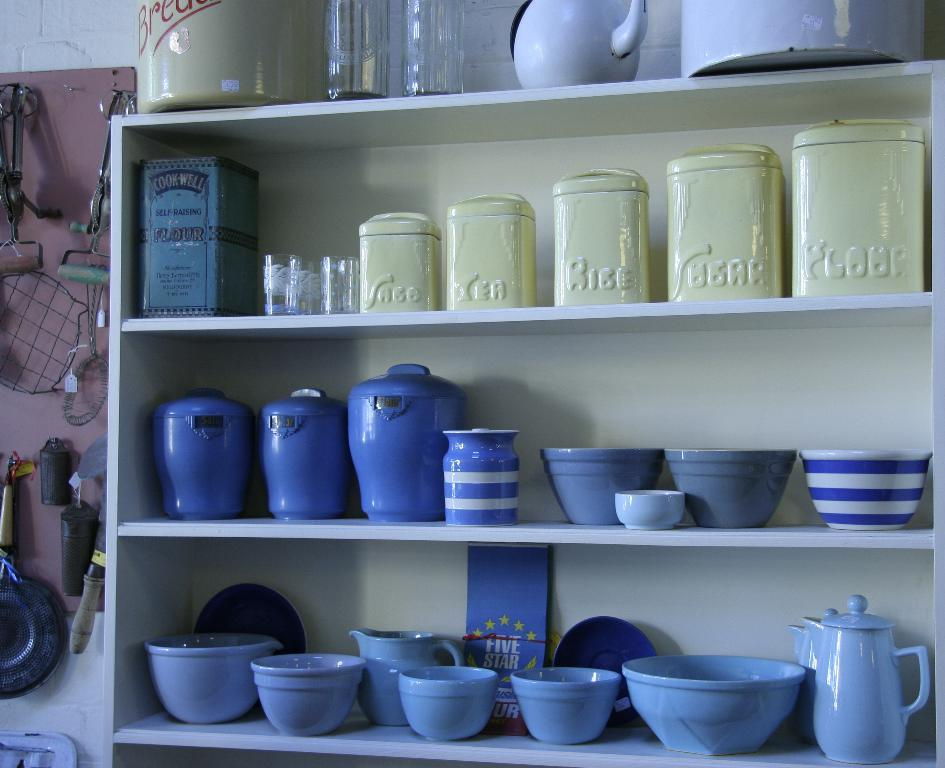What types of containers are visible in the image? There are bowls, cups, and glasses in the image. What else can be found on the shelves in the image? There are other utensils on the shelves in the image. What is located on the left side of the image? There are kitchen accessories on the left side of the image. Can you hear the sound of a spoon stirring in the image? There is no sound present in the image, as it is a still photograph. 